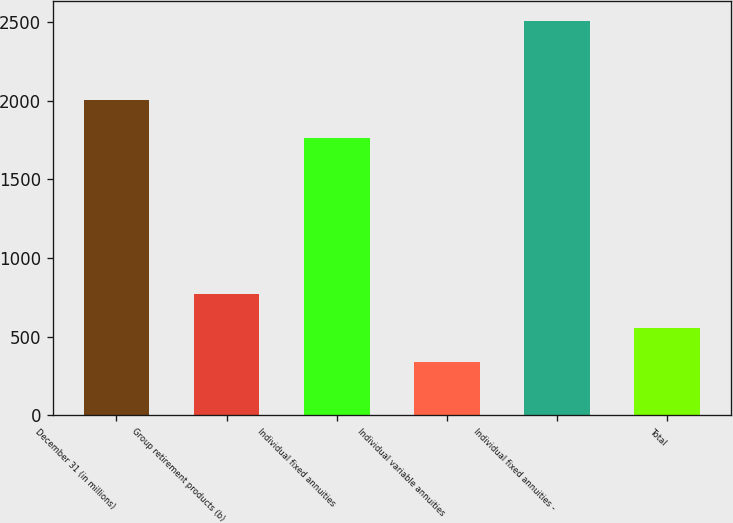<chart> <loc_0><loc_0><loc_500><loc_500><bar_chart><fcel>December 31 (in millions)<fcel>Group retirement products (b)<fcel>Individual fixed annuities<fcel>Individual variable annuities<fcel>Individual fixed annuities -<fcel>Total<nl><fcel>2005<fcel>770.4<fcel>1759<fcel>336<fcel>2508<fcel>553.2<nl></chart> 